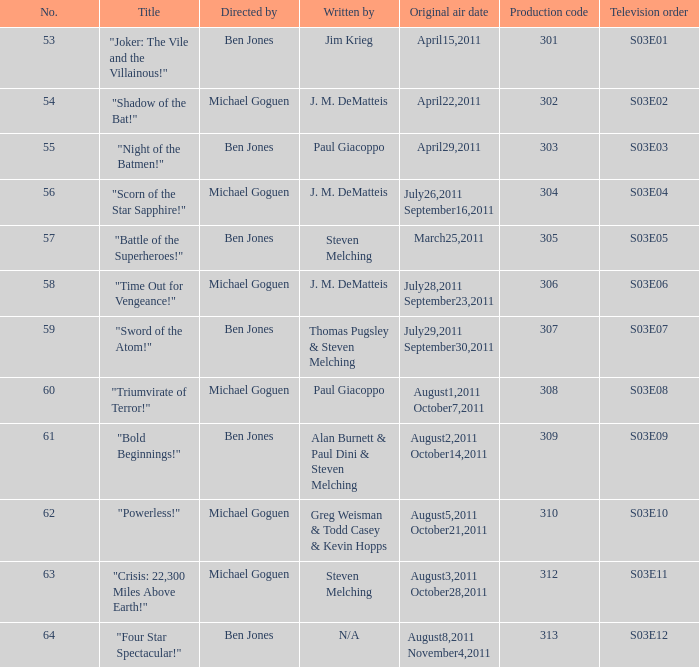What is the original air date of the episode directed by ben jones and written by steven melching?  March25,2011. 